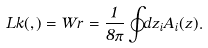<formula> <loc_0><loc_0><loc_500><loc_500>L k ( \Gamma , \Gamma ) = W r = \frac { 1 } { 8 \pi } \oint _ { \Gamma } d z _ { i } A _ { i } ( z ) .</formula> 